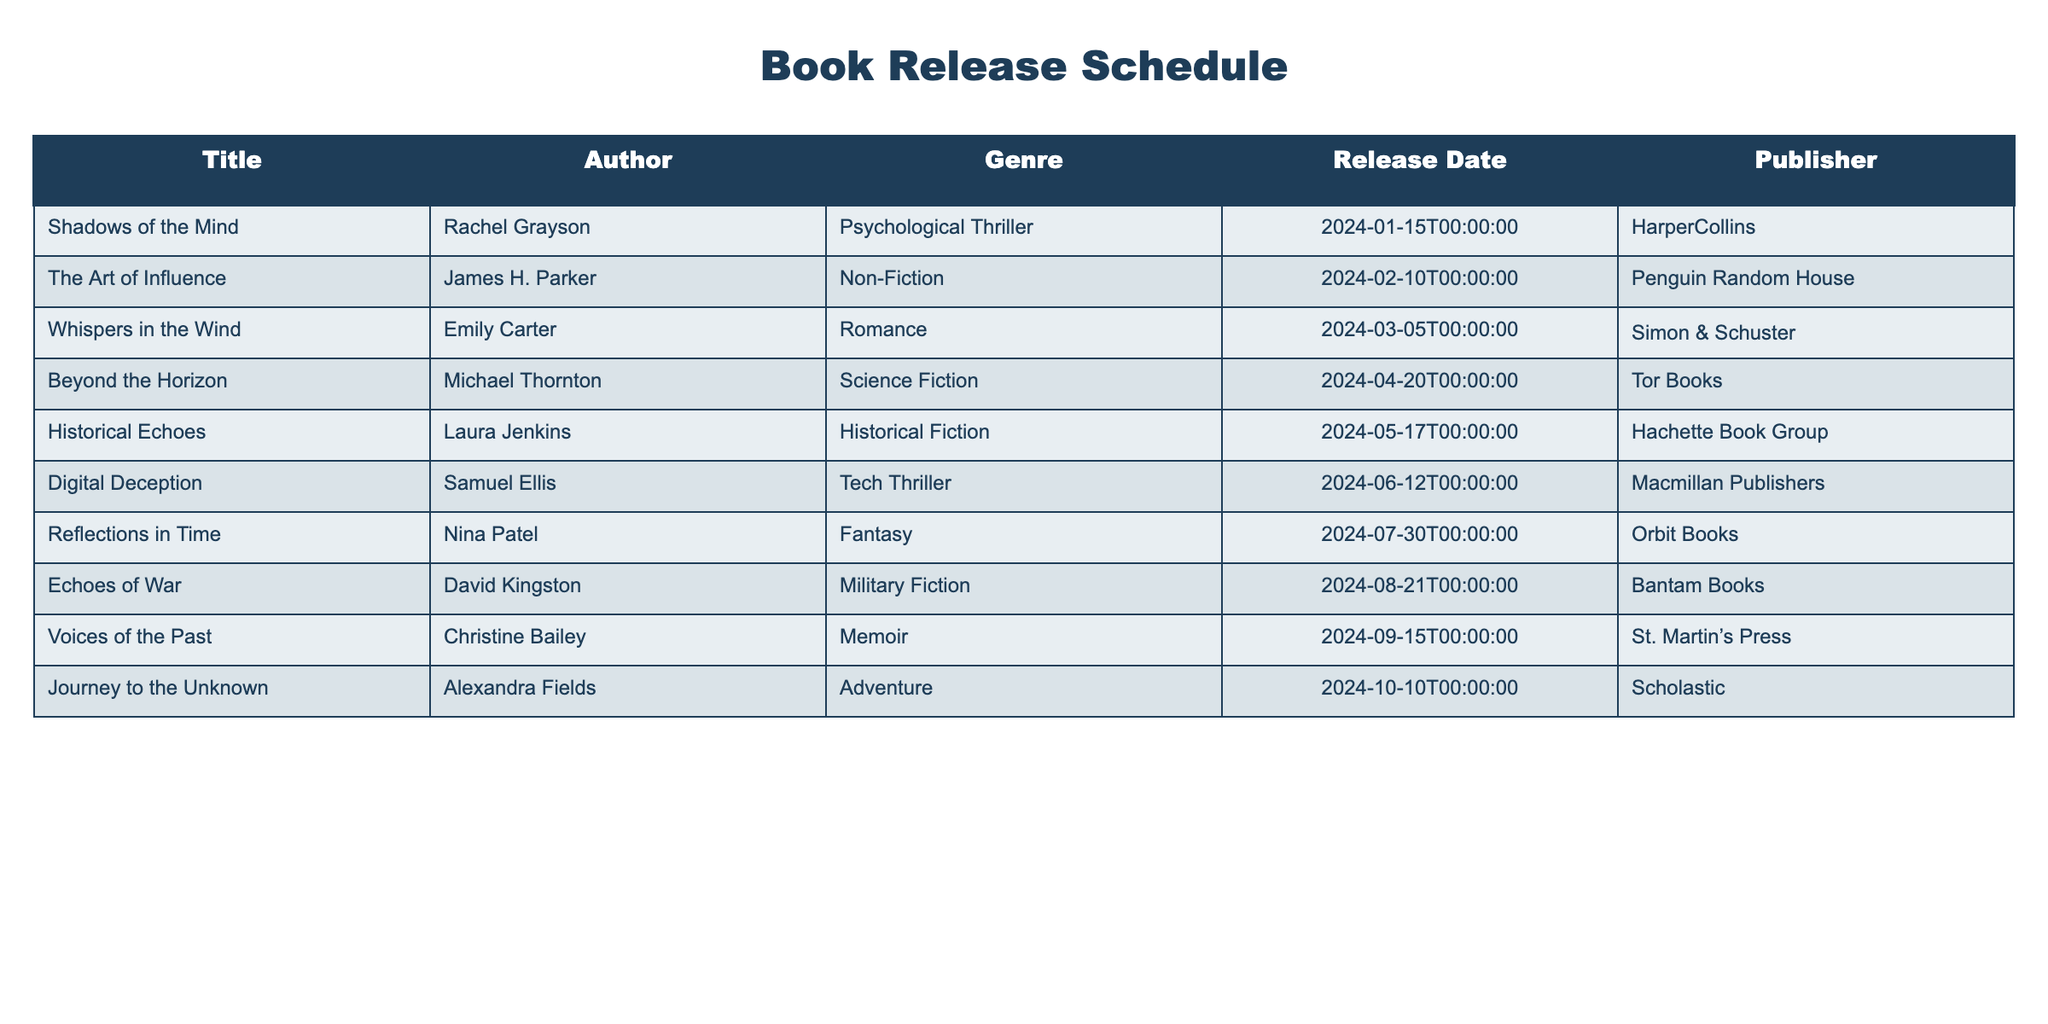What is the release date of "Beyond the Horizon"? The release date for "Beyond the Horizon," authored by Michael Thornton, is listed directly under the Release Date column. Looking at the table, the corresponding date is April 20, 2024.
Answer: April 20, 2024 Which genre does "Digital Deception" belong to? The genre of a book can be found in the Genre column. For "Digital Deception," which is authored by Samuel Ellis, the table states that it falls within the Tech Thriller genre.
Answer: Tech Thriller Is "The Art of Influence" published by Penguin Random House? To determine this, we can look at the Publisher column for "The Art of Influence" by James H. Parker. The table indicates it is indeed published by Penguin Random House, confirming the statement as true.
Answer: Yes How many romance books are scheduled for release? We scan the table to identify books labeled as Romance within the Genre column. The only title listed under this genre is "Whispers in the Wind," authored by Emily Carter. Thus, the total count of romance books is one.
Answer: 1 Which book has the latest release date? The latest release date can be found by comparing the Release Date column across all entries. The last date in the table is October 10, 2024, which corresponds to "Journey to the Unknown" by Alexandra Fields. This makes it the book with the latest release date.
Answer: Journey to the Unknown What is the average release month for the listed books? To find the average release month, we convert the release dates into months: January (1), February (2), March (3), April (4), May (5), June (6), July (7), August (8), September (9), and October (10). Counting these, the sum of the month numbers is 55, and there are 10 books, making the average month 55/10 = 5.5, which corresponds to May.
Answer: May How many authors have names that start with the letter 'A'? We will look at the Author column and count the entries that start with 'A'. The names that fit this criteria in the table are "Alexandra Fields" and "Andrew Hart." There are a total of two authors whose names start with 'A.'
Answer: 2 Is "Historical Echoes" the only Historical Fiction book scheduled for release in the upcoming year? Examining the Genre column for the term "Historical Fiction," we find "Historical Echoes" by Laura Jenkins listed alone under this category without any other similar titles. Thus, it is the only one scheduled for the upcoming year.
Answer: Yes What is the total number of books scheduled for release after June 2024? The books scheduled for release after June 2024 can be identified by reviewing the Release Date column. The titles are "Reflections in Time" (July), "Echoes of War" (August), "Voices of the Past" (September), and "Journey to the Unknown" (October), leading to a total of four books.
Answer: 4 